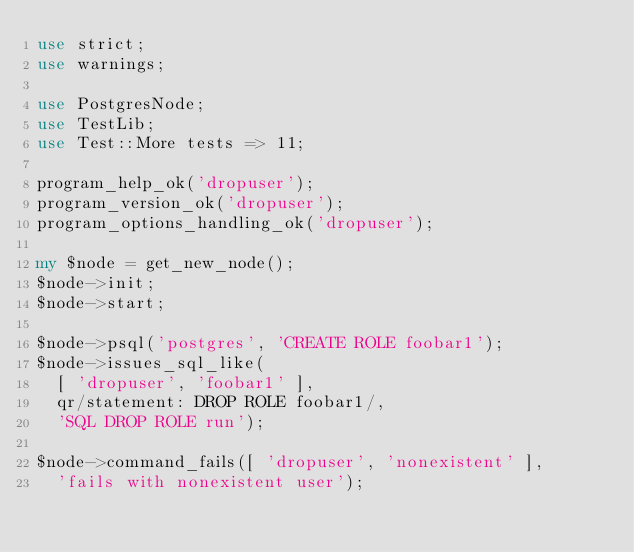<code> <loc_0><loc_0><loc_500><loc_500><_Perl_>use strict;
use warnings;

use PostgresNode;
use TestLib;
use Test::More tests => 11;

program_help_ok('dropuser');
program_version_ok('dropuser');
program_options_handling_ok('dropuser');

my $node = get_new_node();
$node->init;
$node->start;

$node->psql('postgres', 'CREATE ROLE foobar1');
$node->issues_sql_like(
	[ 'dropuser', 'foobar1' ],
	qr/statement: DROP ROLE foobar1/,
	'SQL DROP ROLE run');

$node->command_fails([ 'dropuser', 'nonexistent' ],
	'fails with nonexistent user');
</code> 